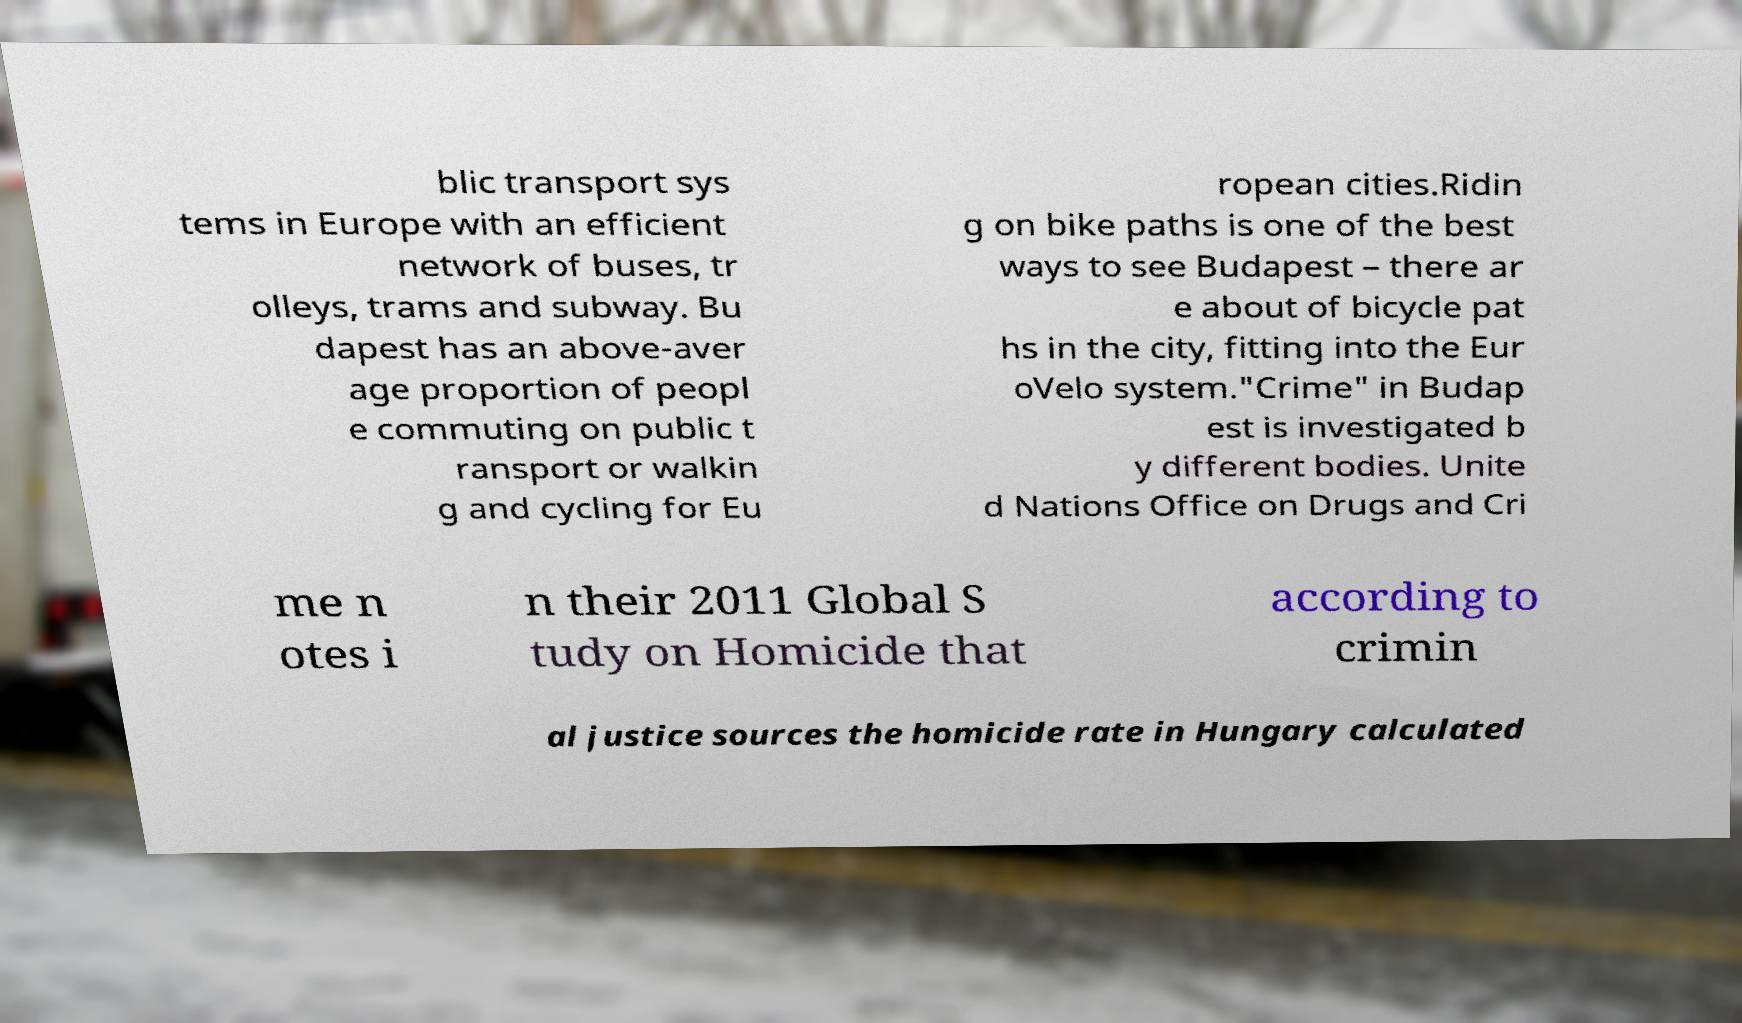Please read and relay the text visible in this image. What does it say? blic transport sys tems in Europe with an efficient network of buses, tr olleys, trams and subway. Bu dapest has an above-aver age proportion of peopl e commuting on public t ransport or walkin g and cycling for Eu ropean cities.Ridin g on bike paths is one of the best ways to see Budapest – there ar e about of bicycle pat hs in the city, fitting into the Eur oVelo system."Crime" in Budap est is investigated b y different bodies. Unite d Nations Office on Drugs and Cri me n otes i n their 2011 Global S tudy on Homicide that according to crimin al justice sources the homicide rate in Hungary calculated 